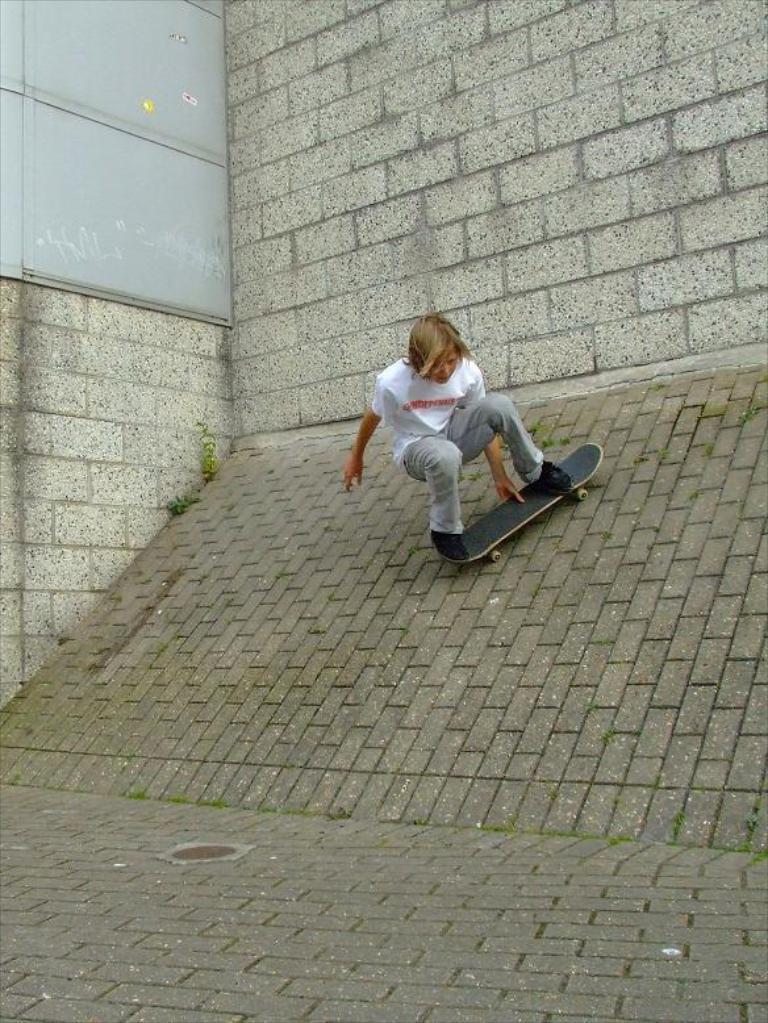In one or two sentences, can you explain what this image depicts? In this image in the center there is one person who is skating, at the bottom there is pavement. And in the center there is slope, and in the background there is a building. 